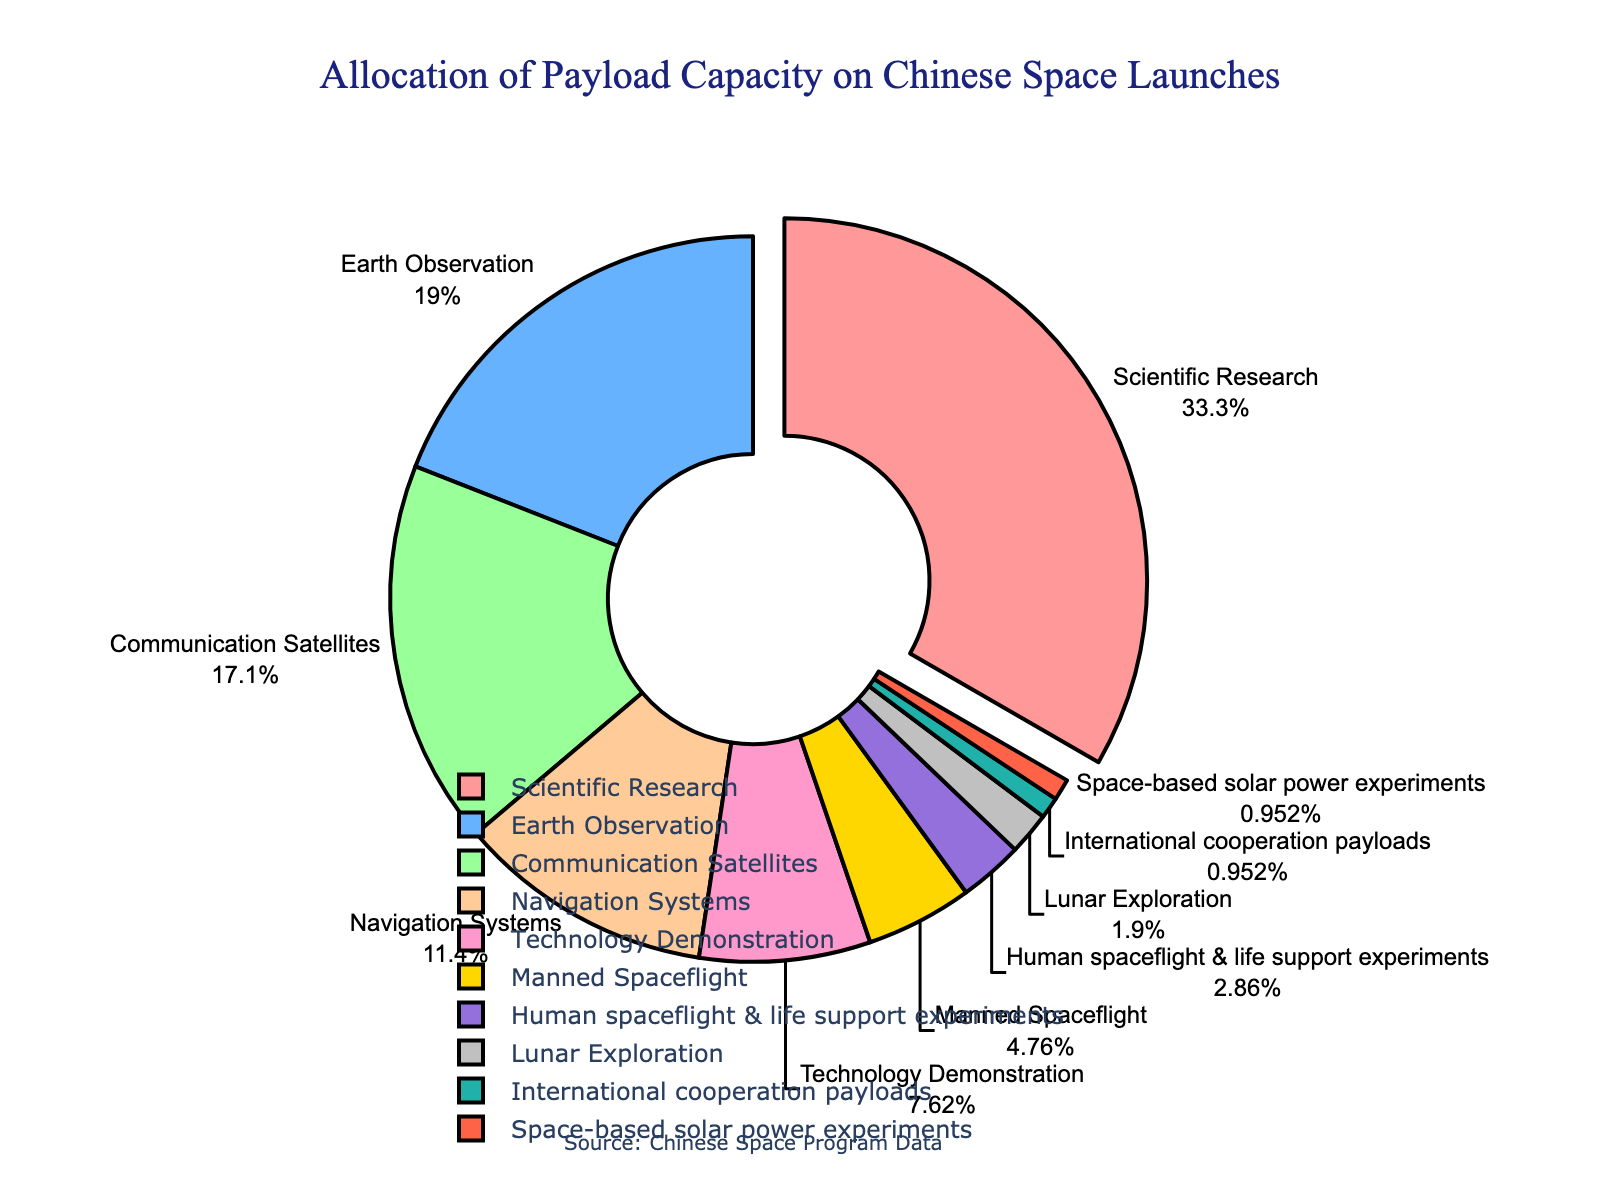What's the total percentage of payload capacity used for communication satellites and earth observation? First, identify the percentage for Communication Satellites (18%) and Earth Observation (20%) from the chart. Then, sum these two values: 18% + 20% = 38%.
Answer: 38% Which purpose has the smallest allocation of payload capacity? Look for the sector with the smallest percentage value. According to the chart, the smallest allocation is 1%, which belongs to both International Cooperation Payloads and Space-based Solar Power Experiments.
Answer: International Cooperation Payloads, Space-based Solar Power Experiments Is the payload capacity for scientific research greater than that for navigation systems? Compare the percentage values for Scientific Research (35%) and Navigation Systems (12%). Since 35% is greater than 12%, the answer is yes.
Answer: Yes By how much is the allocation of manned spaceflight greater than that of lunar exploration? Identify the percentages for Manned Spaceflight (5%) and Lunar Exploration (2%). Subtract the smaller from the larger: 5% - 2% = 3%.
Answer: 3% What percentage of the payload capacity is dedicated to technology demonstration, manned spaceflight, and lunar exploration combined? Identify the percentage values for Technology Demonstration (8%), Manned Spaceflight (5%), and Lunar Exploration (2%). Sum these values: 8% + 5% + 2% = 15%.
Answer: 15% Which category occupies the largest section in the pie chart? Look for the sector with the largest pie slice. Scientific Research holds 35%, making it the largest.
Answer: Scientific Research Which categories have a combined payload capacity equal to or exceeding that of scientific research? Scientific Research has 35%. Check if any combinations of other categories meet or exceed this. For instance, Earth Observation (20%) + Communication Satellites (18%) = 38%, which exceeds 35%.
Answer: Earth Observation and Communication Satellites What is the total percentage of payload capacity used for technology demonstration plus human spaceflight & life support experiments? Identify the percentages for Technology Demonstration (8%) and Human Spaceflight & Life Support Experiments (3%). Sum these values: 8% + 3% = 11%.
Answer: 11% What is the ratio of the payload capacity allocation between communication satellites and navigation systems? Identify the percentages for Communication Satellites (18%) and Navigation Systems (12%). Form the ratio: 18:12, which can be simplified to 3:2.
Answer: 3:2 What fraction of the payload capacity is dedicated to international cooperation payloads out of the total capacity? Identify the percentage for International Cooperation Payloads (1%). Since the total capacity is 100%, this simplifies to 1/100.
Answer: 1/100 